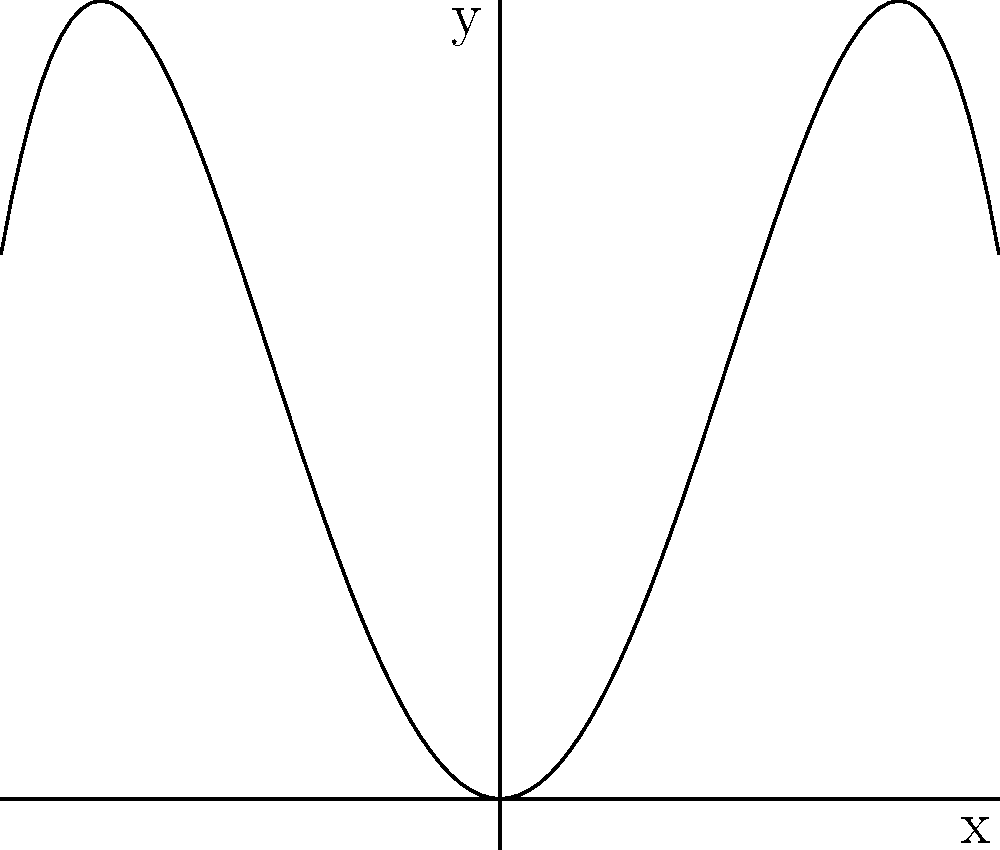In your latest artwork inspired by traditional Lebanese architectural arches, you've created a polynomial curve represented by the function $f(x) = -0.25x^4 + 2x^2$. Analyze the symmetry of this curve and determine its axis of symmetry. To determine the axis of symmetry for the polynomial $f(x) = -0.25x^4 + 2x^2$, we can follow these steps:

1. Observe that this is an even-degree polynomial (degree 4) with only even powers of x.

2. Even functions are symmetric about the y-axis, meaning $f(x) = f(-x)$ for all x.

3. To verify:
   $f(x) = -0.25x^4 + 2x^2$
   $f(-x) = -0.25(-x)^4 + 2(-x)^2 = -0.25x^4 + 2x^2$

4. Since $f(x) = f(-x)$, the function is indeed symmetric about the y-axis.

5. The y-axis has the equation $x = 0$.

Therefore, the axis of symmetry for this polynomial curve, which resembles a traditional Lebanese arch, is the y-axis, or $x = 0$.
Answer: $x = 0$ 